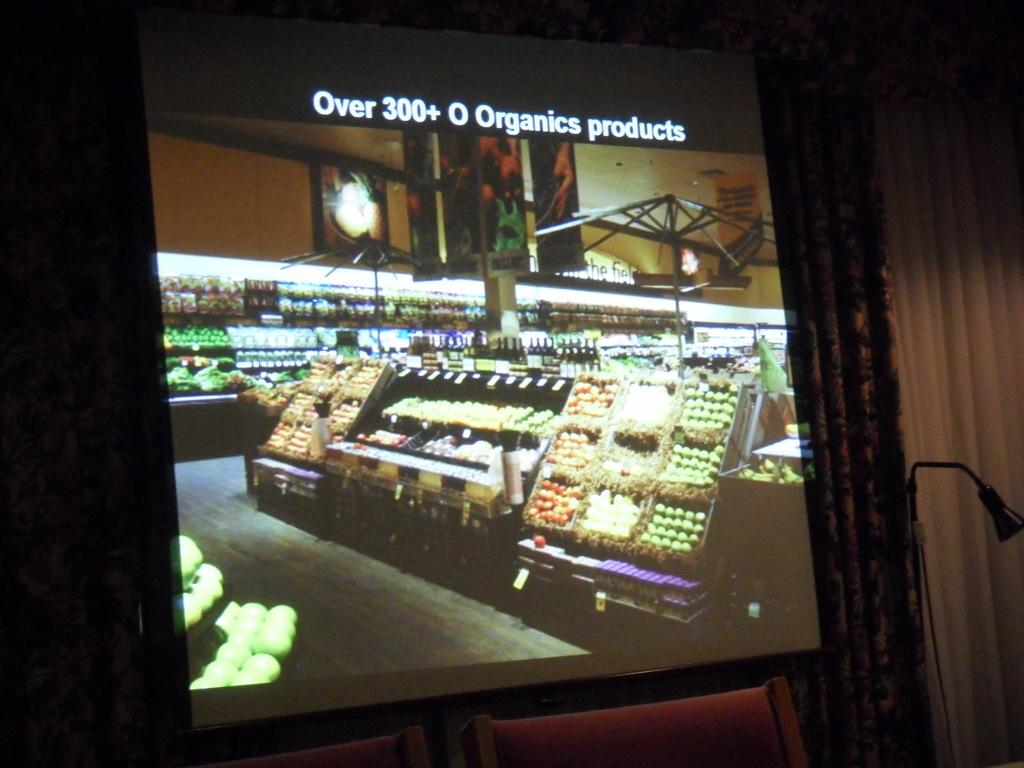<image>
Write a terse but informative summary of the picture. A grocery store has over 300 organic products. 